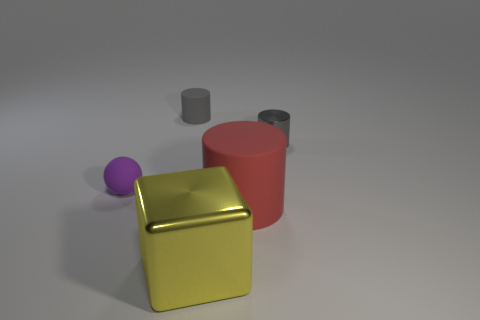What is the size of the red object that is the same shape as the gray metal thing?
Provide a short and direct response. Large. The tiny matte thing behind the tiny rubber thing in front of the small gray metallic cylinder is what shape?
Offer a very short reply. Cylinder. Is there any other thing that is the same color as the metallic cylinder?
Your answer should be very brief. Yes. How many objects are tiny brown rubber things or small purple spheres?
Make the answer very short. 1. Are there any yellow cubes of the same size as the red matte cylinder?
Provide a succinct answer. Yes. What is the shape of the tiny gray metal object?
Provide a succinct answer. Cylinder. Is the number of big objects behind the yellow cube greater than the number of red cylinders to the left of the sphere?
Offer a very short reply. Yes. Do the tiny object that is to the right of the block and the tiny cylinder that is to the left of the large yellow cube have the same color?
Ensure brevity in your answer.  Yes. The purple matte thing that is the same size as the gray metal object is what shape?
Your answer should be very brief. Sphere. Is there a red rubber object that has the same shape as the small shiny object?
Your answer should be very brief. Yes. 